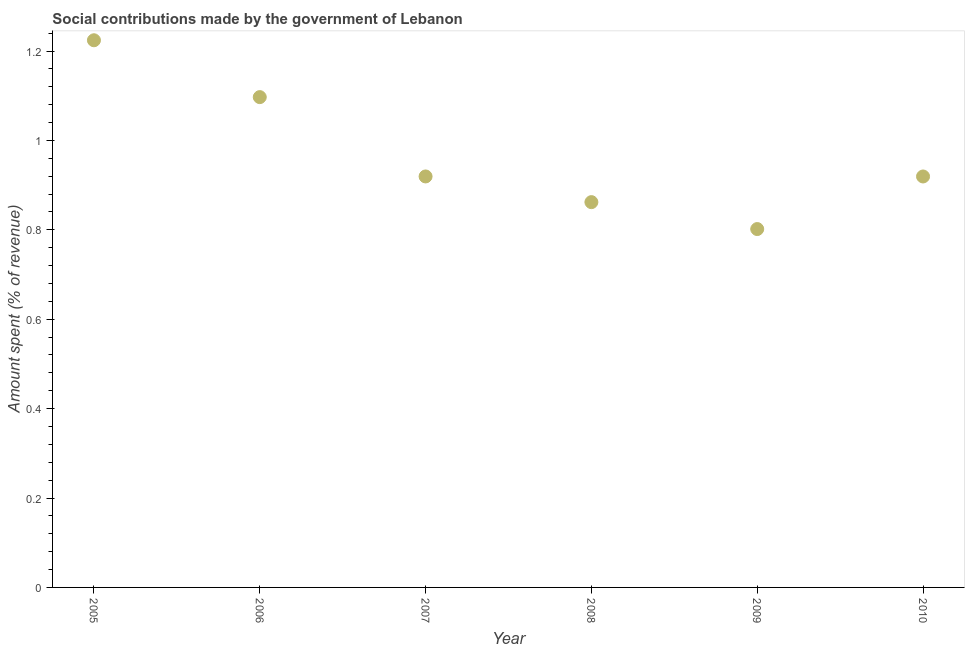What is the amount spent in making social contributions in 2009?
Keep it short and to the point. 0.8. Across all years, what is the maximum amount spent in making social contributions?
Make the answer very short. 1.22. Across all years, what is the minimum amount spent in making social contributions?
Give a very brief answer. 0.8. In which year was the amount spent in making social contributions maximum?
Keep it short and to the point. 2005. What is the sum of the amount spent in making social contributions?
Your answer should be compact. 5.82. What is the difference between the amount spent in making social contributions in 2007 and 2008?
Make the answer very short. 0.06. What is the average amount spent in making social contributions per year?
Provide a short and direct response. 0.97. What is the median amount spent in making social contributions?
Offer a terse response. 0.92. In how many years, is the amount spent in making social contributions greater than 0.7600000000000001 %?
Ensure brevity in your answer.  6. Do a majority of the years between 2007 and 2005 (inclusive) have amount spent in making social contributions greater than 0.2 %?
Your response must be concise. No. What is the ratio of the amount spent in making social contributions in 2008 to that in 2010?
Your response must be concise. 0.94. Is the amount spent in making social contributions in 2008 less than that in 2009?
Ensure brevity in your answer.  No. What is the difference between the highest and the second highest amount spent in making social contributions?
Give a very brief answer. 0.13. What is the difference between the highest and the lowest amount spent in making social contributions?
Your response must be concise. 0.42. Does the amount spent in making social contributions monotonically increase over the years?
Your answer should be compact. No. What is the difference between two consecutive major ticks on the Y-axis?
Your answer should be very brief. 0.2. Are the values on the major ticks of Y-axis written in scientific E-notation?
Provide a succinct answer. No. What is the title of the graph?
Offer a terse response. Social contributions made by the government of Lebanon. What is the label or title of the Y-axis?
Make the answer very short. Amount spent (% of revenue). What is the Amount spent (% of revenue) in 2005?
Make the answer very short. 1.22. What is the Amount spent (% of revenue) in 2006?
Offer a terse response. 1.1. What is the Amount spent (% of revenue) in 2007?
Keep it short and to the point. 0.92. What is the Amount spent (% of revenue) in 2008?
Make the answer very short. 0.86. What is the Amount spent (% of revenue) in 2009?
Give a very brief answer. 0.8. What is the Amount spent (% of revenue) in 2010?
Your answer should be very brief. 0.92. What is the difference between the Amount spent (% of revenue) in 2005 and 2006?
Keep it short and to the point. 0.13. What is the difference between the Amount spent (% of revenue) in 2005 and 2007?
Ensure brevity in your answer.  0.3. What is the difference between the Amount spent (% of revenue) in 2005 and 2008?
Provide a short and direct response. 0.36. What is the difference between the Amount spent (% of revenue) in 2005 and 2009?
Give a very brief answer. 0.42. What is the difference between the Amount spent (% of revenue) in 2005 and 2010?
Ensure brevity in your answer.  0.3. What is the difference between the Amount spent (% of revenue) in 2006 and 2007?
Ensure brevity in your answer.  0.18. What is the difference between the Amount spent (% of revenue) in 2006 and 2008?
Ensure brevity in your answer.  0.23. What is the difference between the Amount spent (% of revenue) in 2006 and 2009?
Provide a succinct answer. 0.3. What is the difference between the Amount spent (% of revenue) in 2006 and 2010?
Provide a succinct answer. 0.18. What is the difference between the Amount spent (% of revenue) in 2007 and 2008?
Offer a terse response. 0.06. What is the difference between the Amount spent (% of revenue) in 2007 and 2009?
Ensure brevity in your answer.  0.12. What is the difference between the Amount spent (% of revenue) in 2007 and 2010?
Offer a terse response. 5e-5. What is the difference between the Amount spent (% of revenue) in 2008 and 2009?
Your response must be concise. 0.06. What is the difference between the Amount spent (% of revenue) in 2008 and 2010?
Ensure brevity in your answer.  -0.06. What is the difference between the Amount spent (% of revenue) in 2009 and 2010?
Provide a succinct answer. -0.12. What is the ratio of the Amount spent (% of revenue) in 2005 to that in 2006?
Provide a succinct answer. 1.12. What is the ratio of the Amount spent (% of revenue) in 2005 to that in 2007?
Provide a short and direct response. 1.33. What is the ratio of the Amount spent (% of revenue) in 2005 to that in 2008?
Your answer should be very brief. 1.42. What is the ratio of the Amount spent (% of revenue) in 2005 to that in 2009?
Give a very brief answer. 1.53. What is the ratio of the Amount spent (% of revenue) in 2005 to that in 2010?
Give a very brief answer. 1.33. What is the ratio of the Amount spent (% of revenue) in 2006 to that in 2007?
Provide a short and direct response. 1.19. What is the ratio of the Amount spent (% of revenue) in 2006 to that in 2008?
Offer a terse response. 1.27. What is the ratio of the Amount spent (% of revenue) in 2006 to that in 2009?
Offer a terse response. 1.37. What is the ratio of the Amount spent (% of revenue) in 2006 to that in 2010?
Make the answer very short. 1.19. What is the ratio of the Amount spent (% of revenue) in 2007 to that in 2008?
Your response must be concise. 1.07. What is the ratio of the Amount spent (% of revenue) in 2007 to that in 2009?
Provide a short and direct response. 1.15. What is the ratio of the Amount spent (% of revenue) in 2007 to that in 2010?
Your response must be concise. 1. What is the ratio of the Amount spent (% of revenue) in 2008 to that in 2009?
Provide a succinct answer. 1.07. What is the ratio of the Amount spent (% of revenue) in 2008 to that in 2010?
Make the answer very short. 0.94. What is the ratio of the Amount spent (% of revenue) in 2009 to that in 2010?
Your response must be concise. 0.87. 